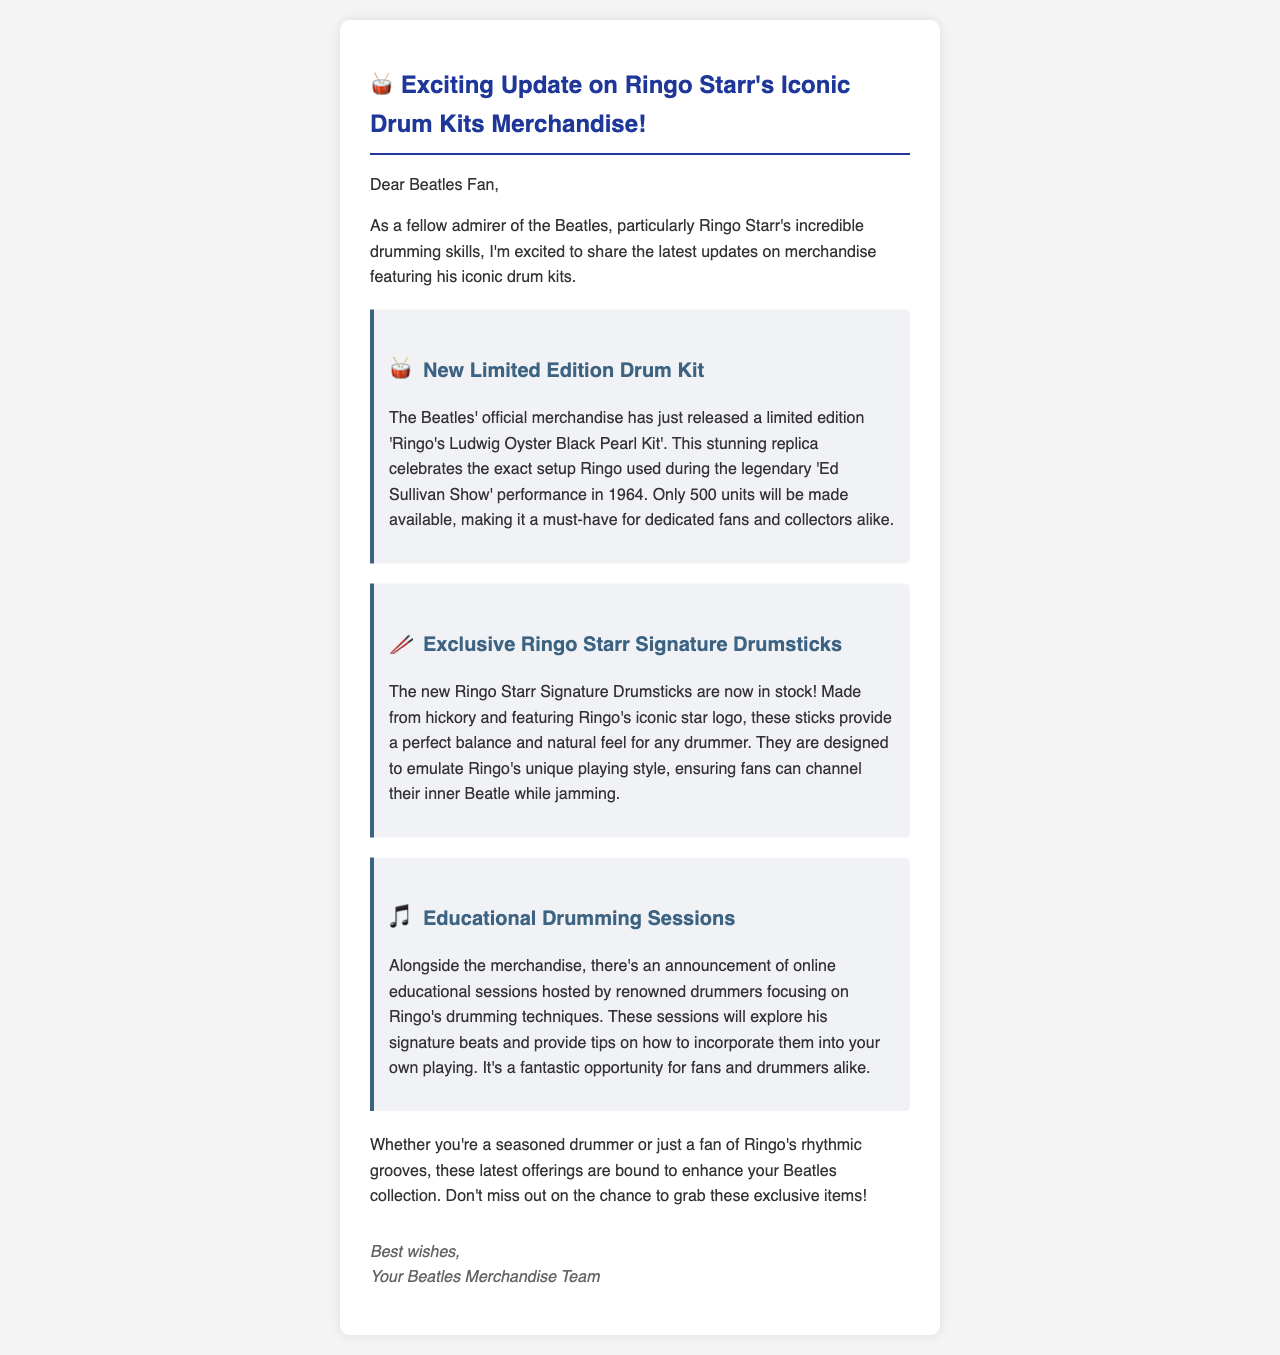What is the name of the limited edition drum kit? The email mentions the limited edition drum kit as 'Ringo's Ludwig Oyster Black Pearl Kit'.
Answer: Ringo's Ludwig Oyster Black Pearl Kit How many units of the limited edition drum kit will be made available? The document states that only 500 units of the limited edition drum kit will be available.
Answer: 500 What material are the new Ringo Starr Signature Drumsticks made from? The email specifically states that the drumsticks are made from hickory.
Answer: Hickory What unique feature do the drumsticks have? The document mentions that the drumsticks feature Ringo's iconic star logo.
Answer: Ringo's iconic star logo What will the online educational sessions explore? The email states that the sessions will explore Ringo's drumming techniques and signature beats.
Answer: Ringo's drumming techniques How is the merchandise expected to appeal to fans? The document indicates that the merchandise enhances the Beatles collection for fans and drummers alike.
Answer: Enhances Beatles collection Who is the intended audience for the educational drumming sessions? The email mentions that both fans and drummers are the intended audience for the educational sessions.
Answer: Fans and drummers What is the email's primary purpose? The primary purpose of the email is to provide an update about the latest Beatles merchandise featuring Ringo Starr.
Answer: Update about latest Beatles merchandise What tone does the email convey to the reader? The email conveys an excited and inviting tone to engage Beatles fans.
Answer: Excited and inviting tone 